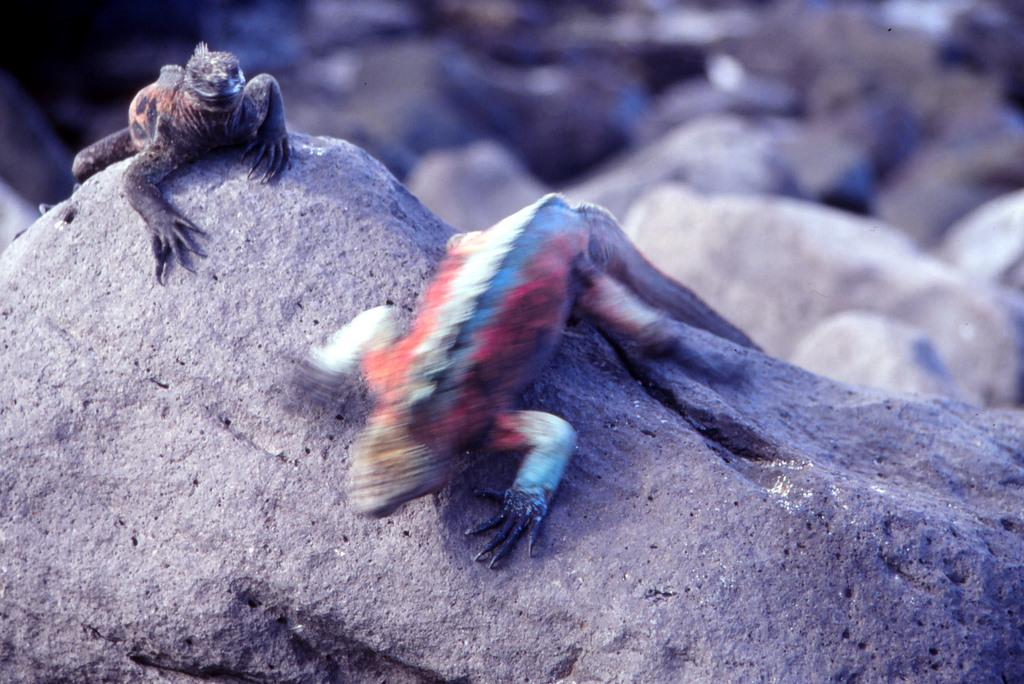What type of animals are in the image? There are reptiles in the image. Where are the reptiles located? The reptiles are on a rock. What other elements can be seen in the image? There are stones visible in the image. What type of attraction is present in the image? There is no attraction present in the image; it features reptiles on a rock with stones visible. 